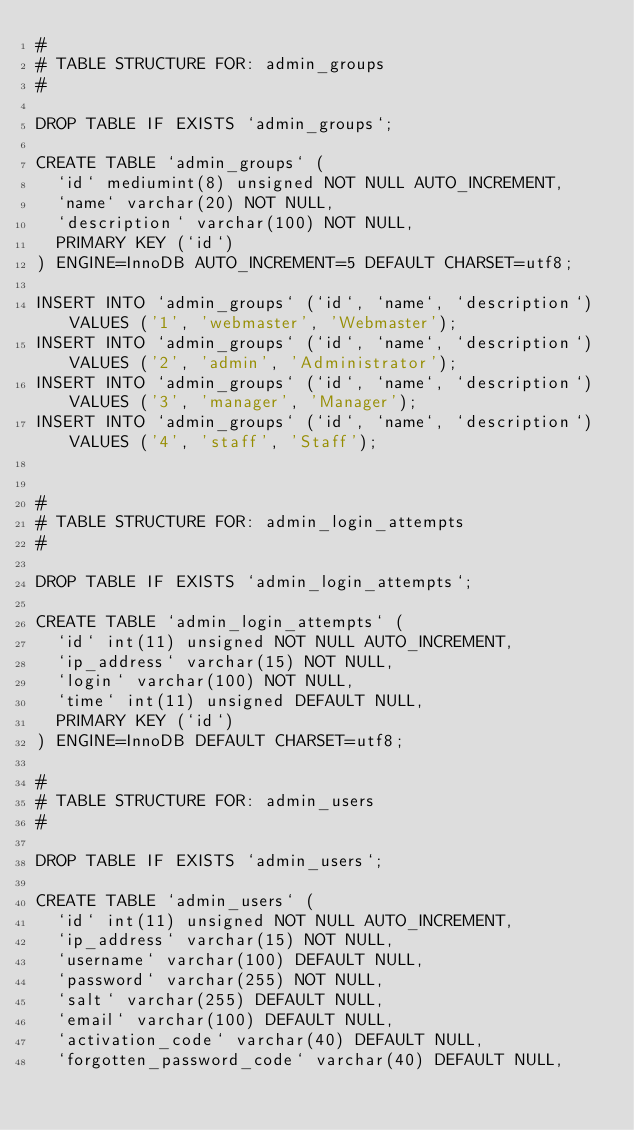Convert code to text. <code><loc_0><loc_0><loc_500><loc_500><_SQL_>#
# TABLE STRUCTURE FOR: admin_groups
#

DROP TABLE IF EXISTS `admin_groups`;

CREATE TABLE `admin_groups` (
  `id` mediumint(8) unsigned NOT NULL AUTO_INCREMENT,
  `name` varchar(20) NOT NULL,
  `description` varchar(100) NOT NULL,
  PRIMARY KEY (`id`)
) ENGINE=InnoDB AUTO_INCREMENT=5 DEFAULT CHARSET=utf8;

INSERT INTO `admin_groups` (`id`, `name`, `description`) VALUES ('1', 'webmaster', 'Webmaster');
INSERT INTO `admin_groups` (`id`, `name`, `description`) VALUES ('2', 'admin', 'Administrator');
INSERT INTO `admin_groups` (`id`, `name`, `description`) VALUES ('3', 'manager', 'Manager');
INSERT INTO `admin_groups` (`id`, `name`, `description`) VALUES ('4', 'staff', 'Staff');


#
# TABLE STRUCTURE FOR: admin_login_attempts
#

DROP TABLE IF EXISTS `admin_login_attempts`;

CREATE TABLE `admin_login_attempts` (
  `id` int(11) unsigned NOT NULL AUTO_INCREMENT,
  `ip_address` varchar(15) NOT NULL,
  `login` varchar(100) NOT NULL,
  `time` int(11) unsigned DEFAULT NULL,
  PRIMARY KEY (`id`)
) ENGINE=InnoDB DEFAULT CHARSET=utf8;

#
# TABLE STRUCTURE FOR: admin_users
#

DROP TABLE IF EXISTS `admin_users`;

CREATE TABLE `admin_users` (
  `id` int(11) unsigned NOT NULL AUTO_INCREMENT,
  `ip_address` varchar(15) NOT NULL,
  `username` varchar(100) DEFAULT NULL,
  `password` varchar(255) NOT NULL,
  `salt` varchar(255) DEFAULT NULL,
  `email` varchar(100) DEFAULT NULL,
  `activation_code` varchar(40) DEFAULT NULL,
  `forgotten_password_code` varchar(40) DEFAULT NULL,</code> 